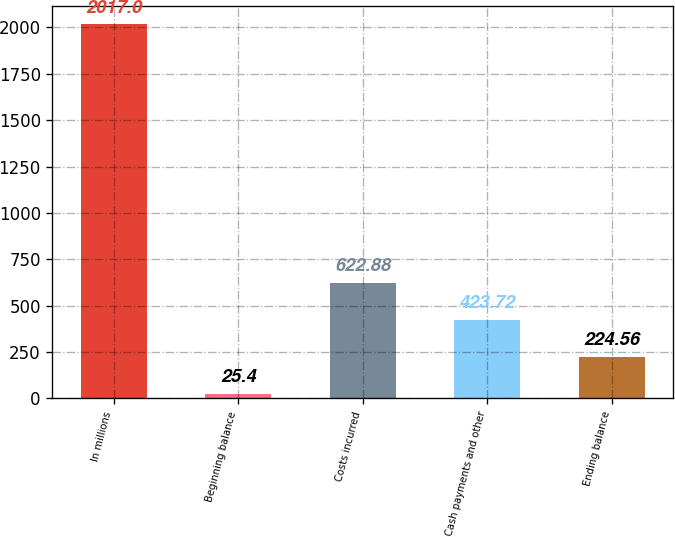Convert chart. <chart><loc_0><loc_0><loc_500><loc_500><bar_chart><fcel>In millions<fcel>Beginning balance<fcel>Costs incurred<fcel>Cash payments and other<fcel>Ending balance<nl><fcel>2017<fcel>25.4<fcel>622.88<fcel>423.72<fcel>224.56<nl></chart> 